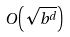<formula> <loc_0><loc_0><loc_500><loc_500>O \left ( { \sqrt { b ^ { d } } } \right )</formula> 